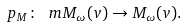Convert formula to latex. <formula><loc_0><loc_0><loc_500><loc_500>p _ { M } \colon \ m M _ { \omega } ( v ) \to M _ { \omega } ( v ) .</formula> 